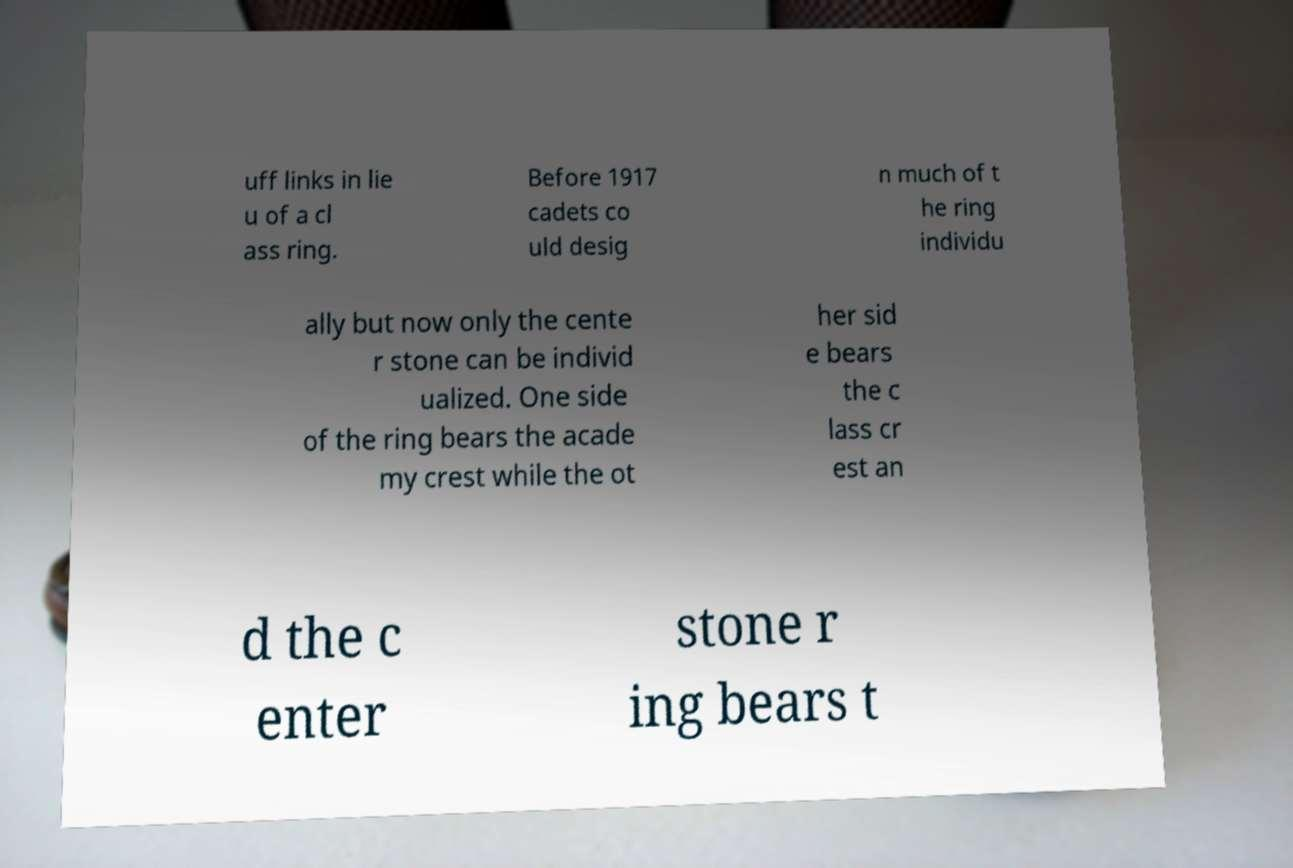There's text embedded in this image that I need extracted. Can you transcribe it verbatim? uff links in lie u of a cl ass ring. Before 1917 cadets co uld desig n much of t he ring individu ally but now only the cente r stone can be individ ualized. One side of the ring bears the acade my crest while the ot her sid e bears the c lass cr est an d the c enter stone r ing bears t 